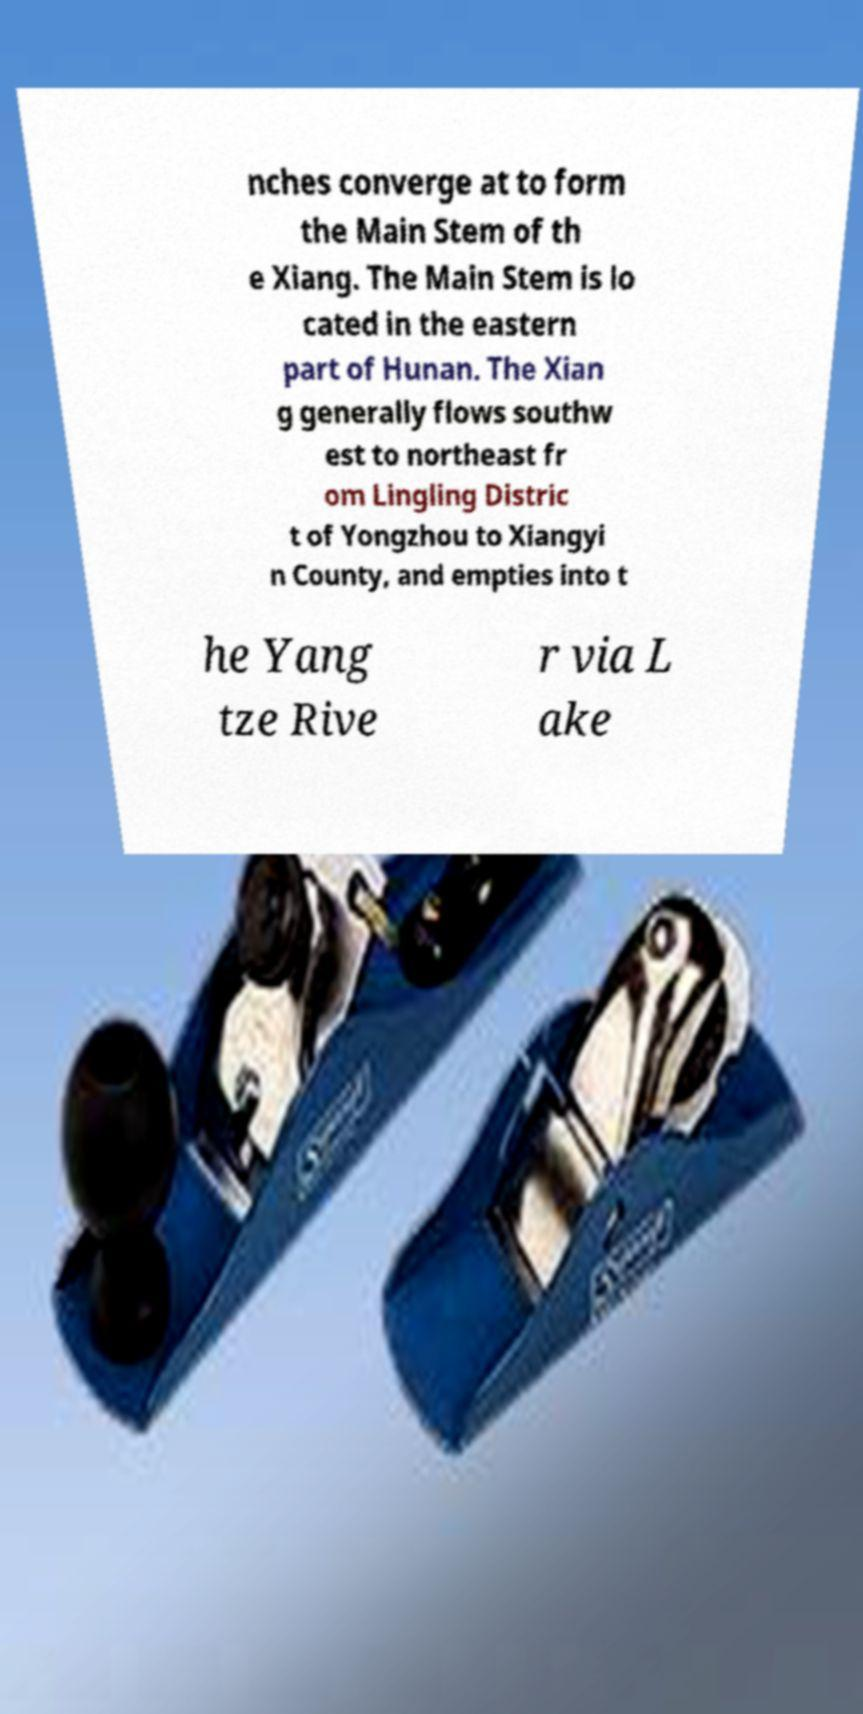Please read and relay the text visible in this image. What does it say? nches converge at to form the Main Stem of th e Xiang. The Main Stem is lo cated in the eastern part of Hunan. The Xian g generally flows southw est to northeast fr om Lingling Distric t of Yongzhou to Xiangyi n County, and empties into t he Yang tze Rive r via L ake 